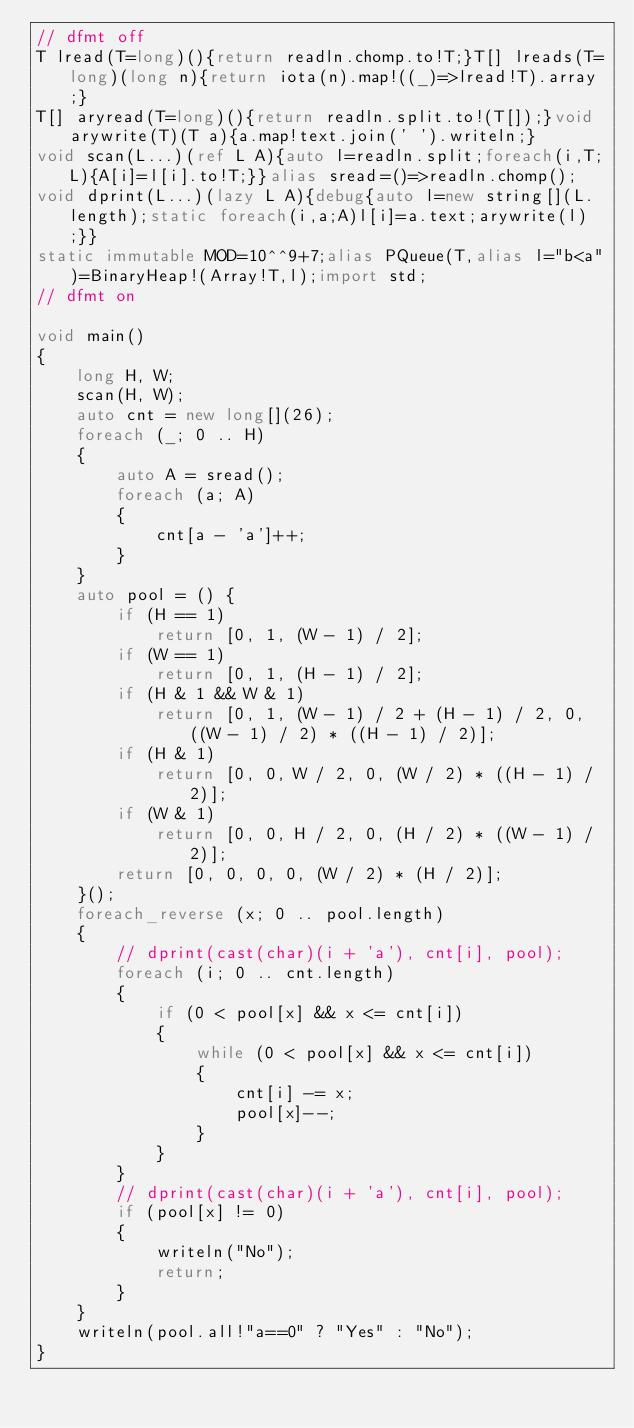Convert code to text. <code><loc_0><loc_0><loc_500><loc_500><_D_>// dfmt off
T lread(T=long)(){return readln.chomp.to!T;}T[] lreads(T=long)(long n){return iota(n).map!((_)=>lread!T).array;}
T[] aryread(T=long)(){return readln.split.to!(T[]);}void arywrite(T)(T a){a.map!text.join(' ').writeln;}
void scan(L...)(ref L A){auto l=readln.split;foreach(i,T;L){A[i]=l[i].to!T;}}alias sread=()=>readln.chomp();
void dprint(L...)(lazy L A){debug{auto l=new string[](L.length);static foreach(i,a;A)l[i]=a.text;arywrite(l);}}
static immutable MOD=10^^9+7;alias PQueue(T,alias l="b<a")=BinaryHeap!(Array!T,l);import std;
// dfmt on

void main()
{
    long H, W;
    scan(H, W);
    auto cnt = new long[](26);
    foreach (_; 0 .. H)
    {
        auto A = sread();
        foreach (a; A)
        {
            cnt[a - 'a']++;
        }
    }
    auto pool = () {
        if (H == 1)
            return [0, 1, (W - 1) / 2];
        if (W == 1)
            return [0, 1, (H - 1) / 2];
        if (H & 1 && W & 1)
            return [0, 1, (W - 1) / 2 + (H - 1) / 2, 0, ((W - 1) / 2) * ((H - 1) / 2)];
        if (H & 1)
            return [0, 0, W / 2, 0, (W / 2) * ((H - 1) / 2)];
        if (W & 1)
            return [0, 0, H / 2, 0, (H / 2) * ((W - 1) / 2)];
        return [0, 0, 0, 0, (W / 2) * (H / 2)];
    }();
    foreach_reverse (x; 0 .. pool.length)
    {
        // dprint(cast(char)(i + 'a'), cnt[i], pool);
        foreach (i; 0 .. cnt.length)
        {
            if (0 < pool[x] && x <= cnt[i])
            {
                while (0 < pool[x] && x <= cnt[i])
                {
                    cnt[i] -= x;
                    pool[x]--;
                }
            }
        }
        // dprint(cast(char)(i + 'a'), cnt[i], pool);
        if (pool[x] != 0)
        {
            writeln("No");
            return;
        }
    }
    writeln(pool.all!"a==0" ? "Yes" : "No");
}
</code> 